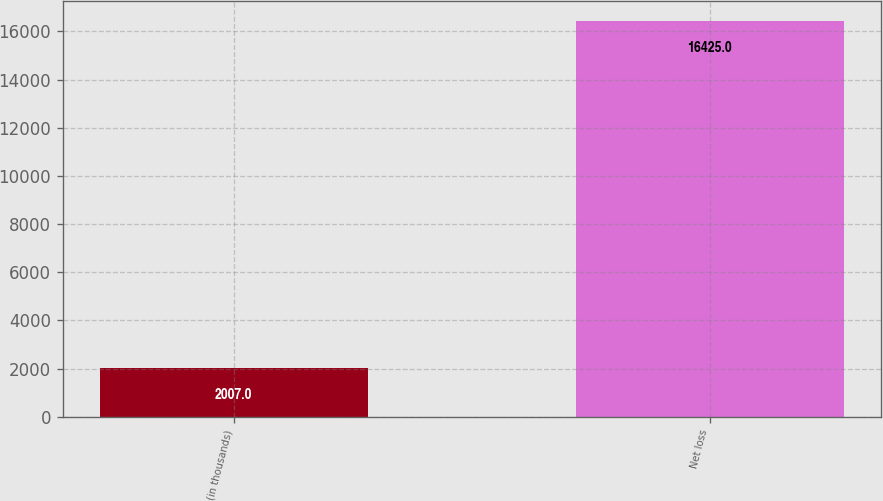<chart> <loc_0><loc_0><loc_500><loc_500><bar_chart><fcel>(in thousands)<fcel>Net loss<nl><fcel>2007<fcel>16425<nl></chart> 